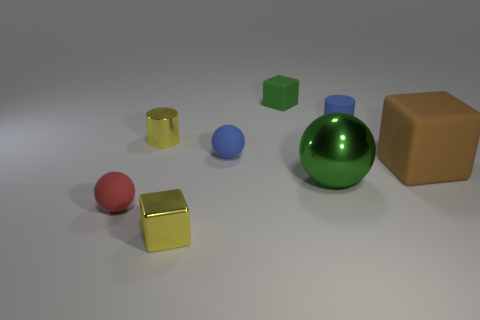Subtract all small spheres. How many spheres are left? 1 Add 2 yellow metal cubes. How many objects exist? 10 Subtract all cylinders. How many objects are left? 6 Add 2 small green blocks. How many small green blocks are left? 3 Add 5 big yellow metallic balls. How many big yellow metallic balls exist? 5 Subtract 0 green cylinders. How many objects are left? 8 Subtract all rubber blocks. Subtract all rubber things. How many objects are left? 1 